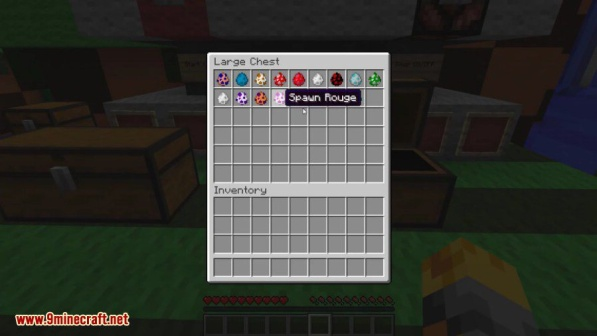What might be the next steps for the player after organizing their inventory? After organizing their inventory, the player might decide to go on an adventure to explore new biomes or structures, such as villages, temples, or strongholds. They could use the spawn eggs to create a farm of various creatures for resources, or they might craft new tools and weapons to prepare for a challenging quest or battle with mobs. Another possibility is that they could focus on building and expanding their base, adding new rooms, decorations, or automated farms. The possibilities are vast and depend on the player's goals and creativity in the game. 